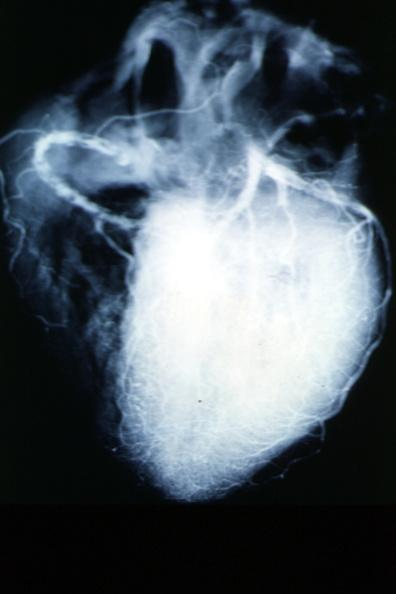what does this image show?
Answer the question using a single word or phrase. X-ray postmortcoronary arteries with multiple lesions 